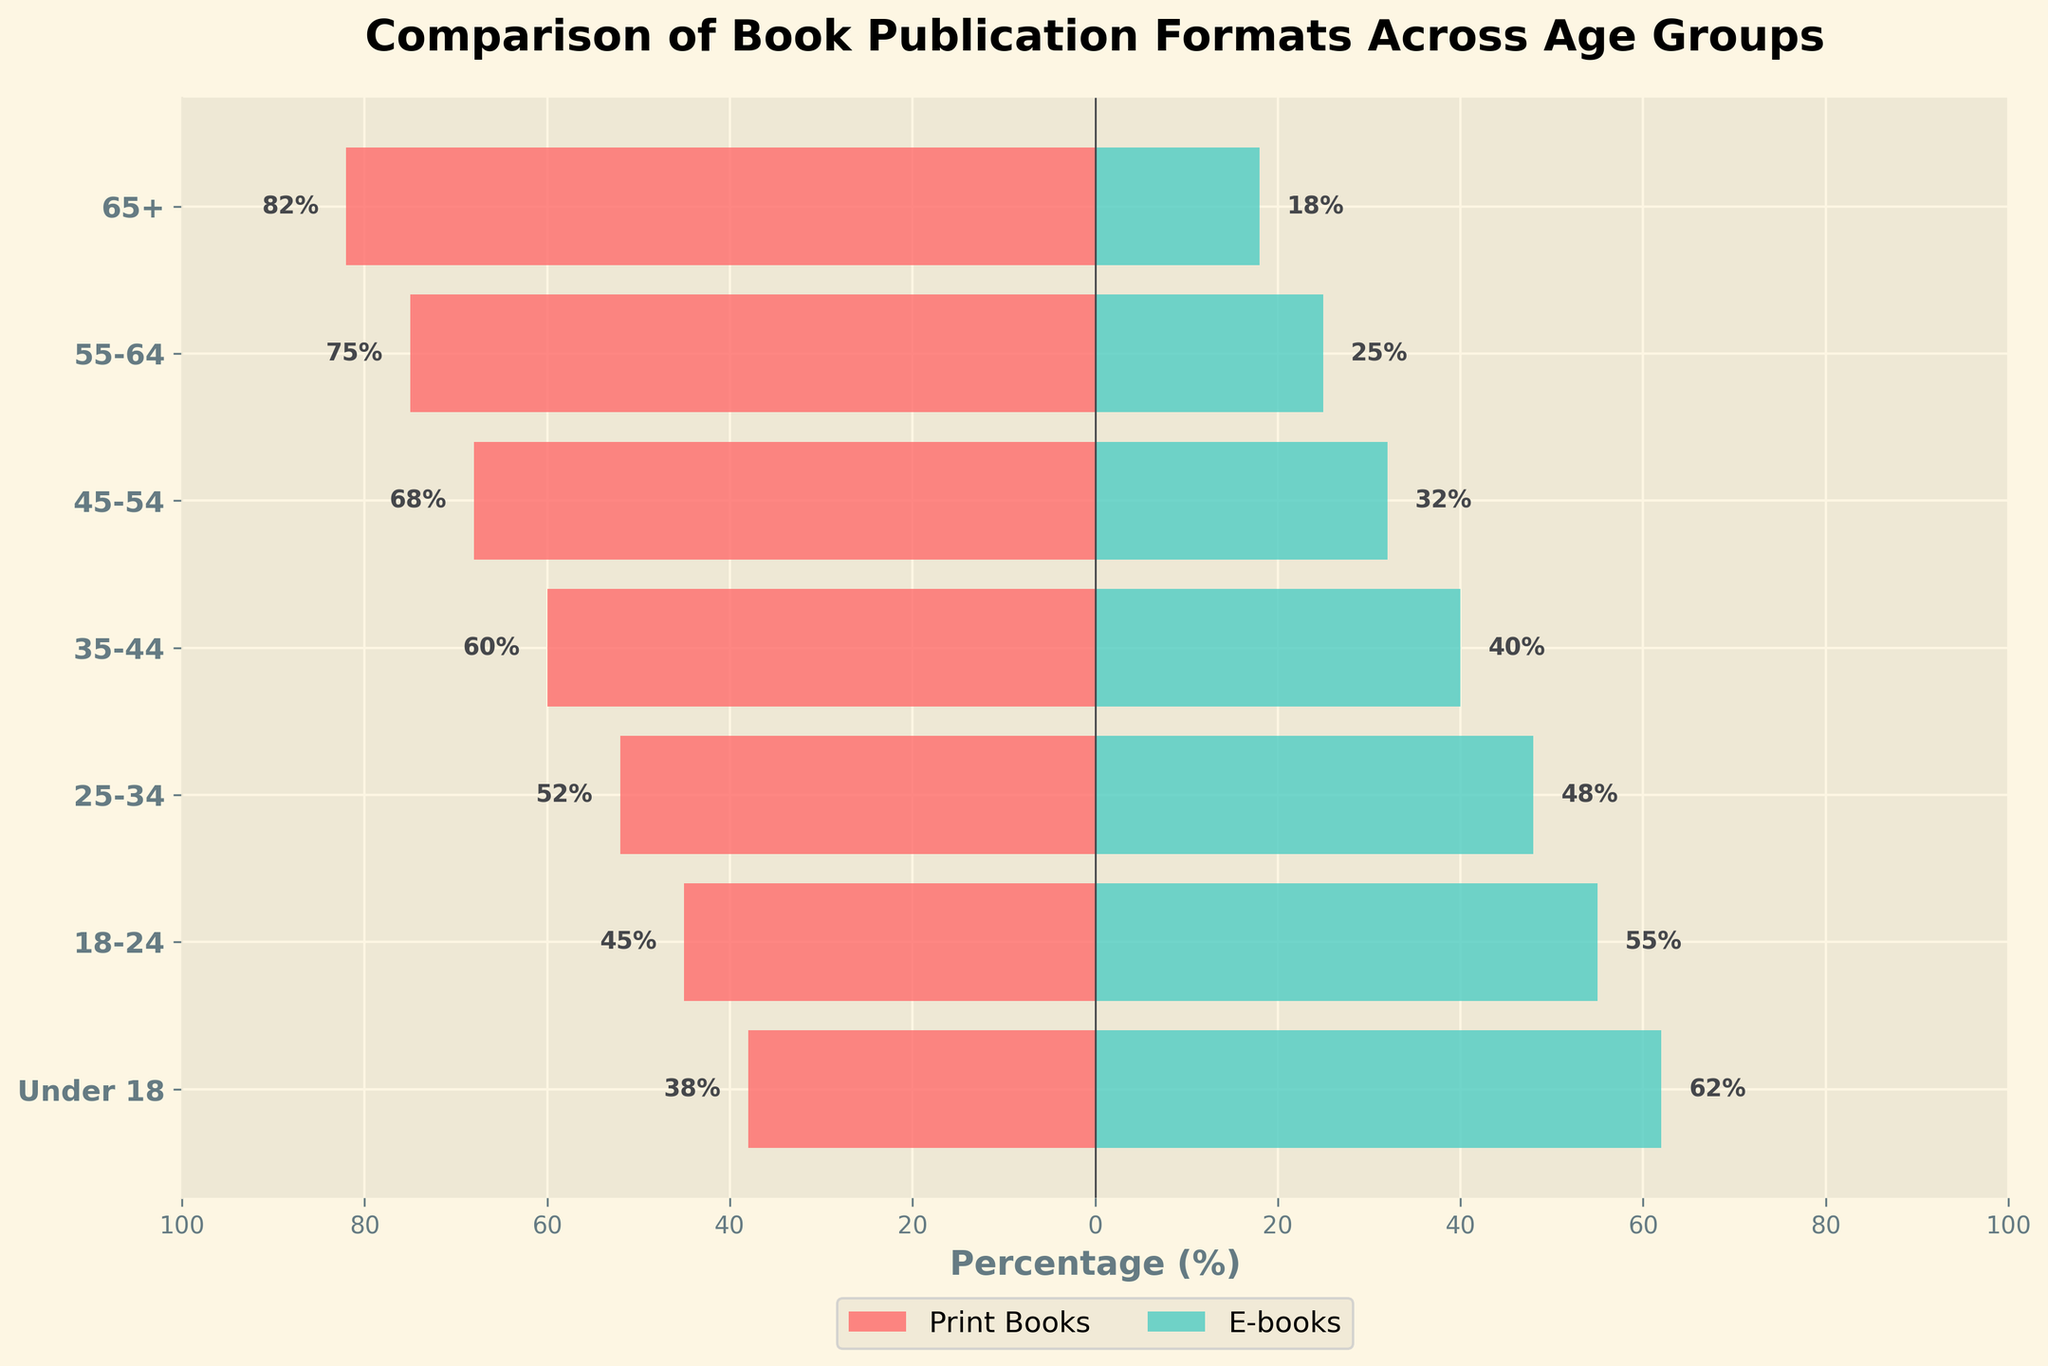What's the percentage of Print Books for the 55-64 age group? Locate the bar representing the 55-64 age group. The length of the bar for Print Books is 75%.
Answer: 75% How many age groups have a higher percentage of E-books compared to Print Books? Compare the lengths of the bars representing Print Books and E-books for each age group. E-books percentages are higher for the age groups Under 18, 18-24, and 25-34, which totals 3 groups.
Answer: 3 Which age group shows the most substantial preference for E-books? Identify the age group where the E-books bar is the longest. This occurs in the Under 18 group with 62%.
Answer: Under 18 What's the difference in Print Book preference between the 65+ and 18-24 age groups? Locate the percentages for Print Books in the 65+ (82%) and 18-24 (45%) age groups, then calculate the difference: 82% - 45% = 37%.
Answer: 37% Which age group has an equal percentage for both Print Books and E-books? Check if any age group shows equal bar lengths for both Print Books and E-books. The 25-34 age group has 52% Print Books and 48% E-books, which are close but not equal. Therefore, there is no such age group.
Answer: None What's the overall trend of E-books preference as age decreases? Examine the lengths of the E-books bars for each age group from oldest to youngest. The trend shows increasing E-books preference with decreasing age, with the Under 18 age group having the highest percentage.
Answer: Increasing By how much does the preference for Print Books decrease from the 45-54 to the 35-44 age group? Calculate the difference between the Print Book percentages of the 45-54 (68%) and 35-44 (60%) age groups: 68% - 60% = 8%.
Answer: 8% What is the median percentage of Print Books across all age groups? Arrange the Print Book percentages for all age groups in ascending order: 38%, 45%, 52%, 60%, 68%, 75%, 82%. The median percentage is the middle value, which is 60%.
Answer: 60% Which age group has the least overall book publication format preference, considering both Print Books and E-books? Adding up the percentages of Print Books and E-books for each age group: 65+ (100%), 55-64 (100%), 45-54 (100%), 35-44 (100%), 25-34 (100%), 18-24 (100%), and Under 18 (100%). Since all groups add up to 100%, no group shows a lesser preference in total; hence, the question is invalid.
Answer: Invalid 